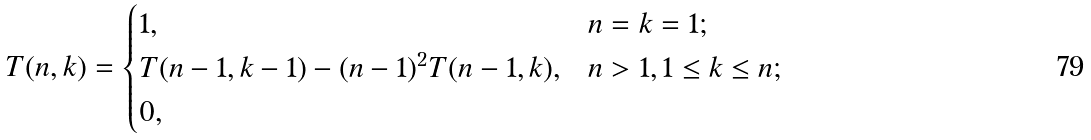Convert formula to latex. <formula><loc_0><loc_0><loc_500><loc_500>T ( n , k ) = \begin{cases} 1 , & n = k = 1 ; \\ T ( n - 1 , k - 1 ) - ( n - 1 ) ^ { 2 } T ( n - 1 , k ) , & n > 1 , 1 \leq k \leq n ; \\ 0 , & \end{cases}</formula> 